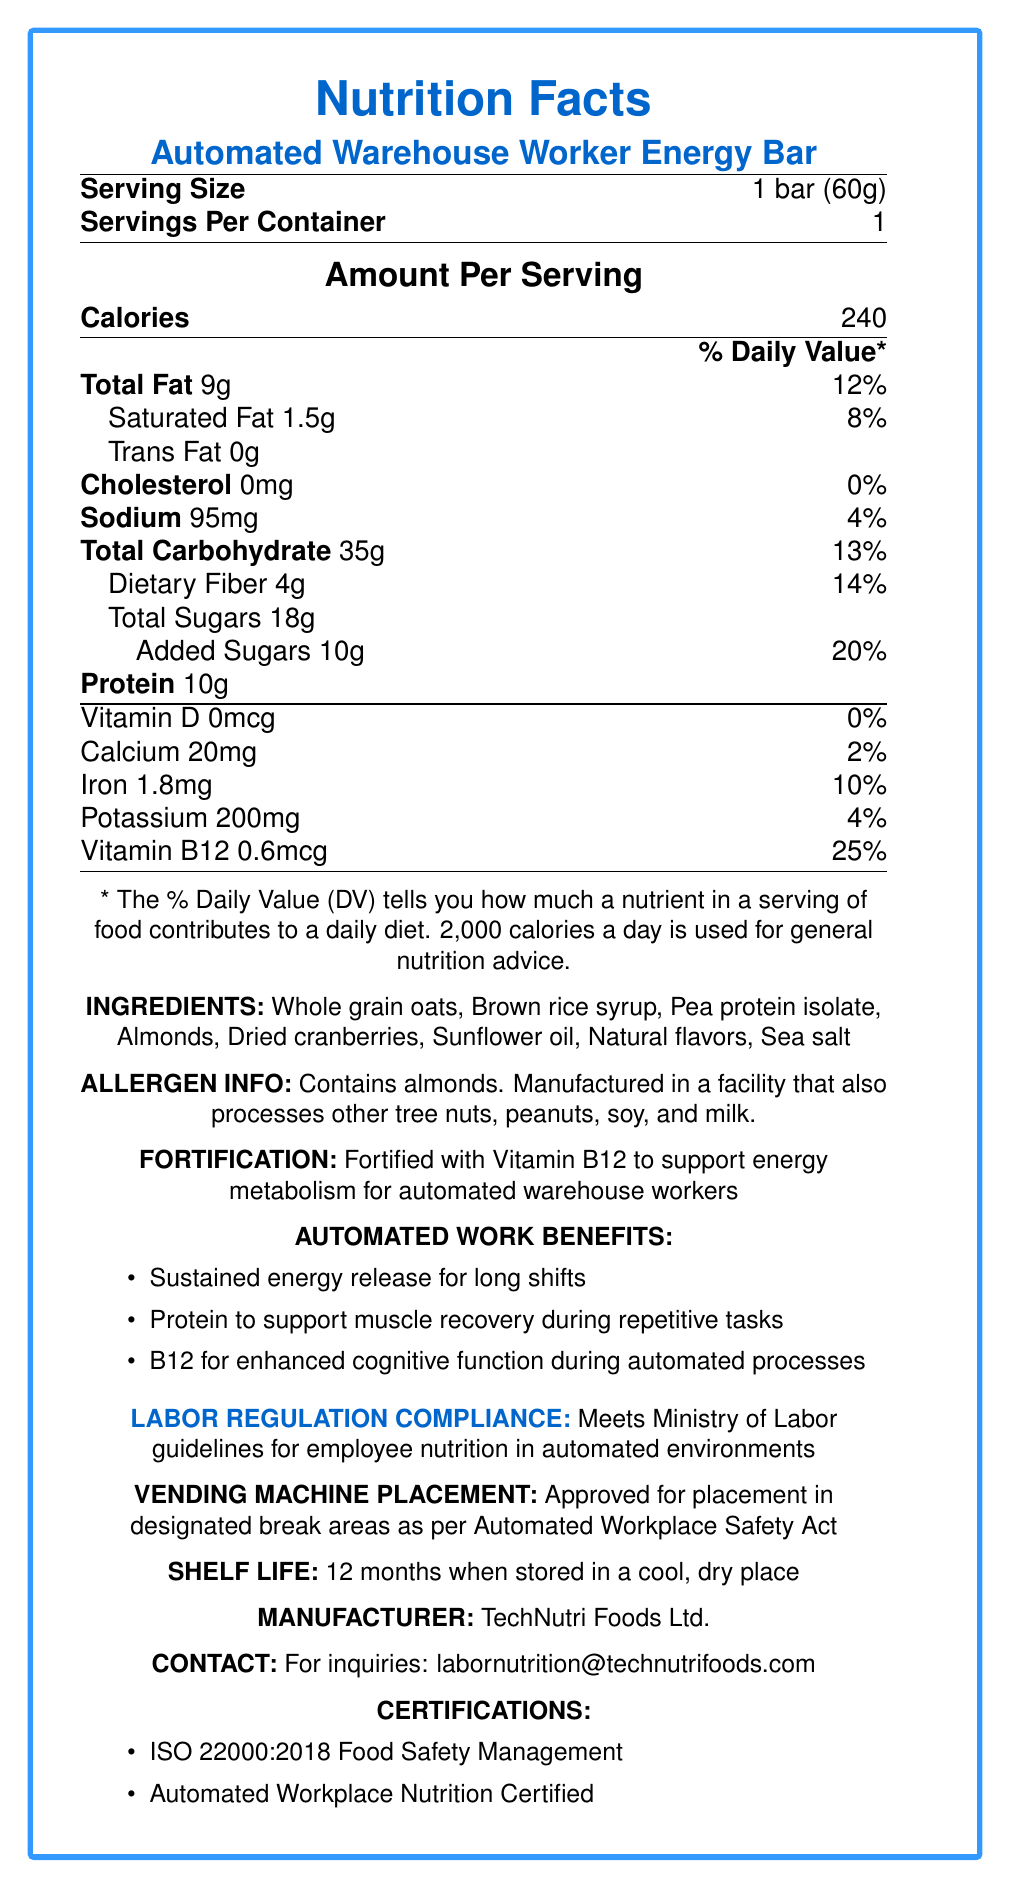how many calories are in one serving of the Automated Warehouse Worker Energy Bar? The document specifies "Calories: 240" under the "Amount Per Serving" section.
Answer: 240 what is the serving size of the energy bar? The serving size is mentioned at the top of the document as "Serving Size: 1 bar (60g)".
Answer: 1 bar (60g) what percentage of the daily value of protein does this energy bar provide? The document lists the amount of protein (10g) but does not specify its percentage of the daily value.
Answer: Not provided what are the main ingredients in the energy bar? These ingredients are listed in the "INGREDIENTS" section of the document.
Answer: Whole grain oats, Brown rice syrup, Pea protein isolate, Almonds, Dried cranberries, Sunflower oil, Natural flavors, Sea salt does the product contain any allergens? The "ALLERGEN INFO" section indicates it contains almonds and is manufactured in a facility that also processes other tree nuts, peanuts, soy, and milk.
Answer: Yes what is the daily value percentage of Vitamin B12 in this energy bar? The document specifies "Vitamin B12 0.6mcg" with a daily value of 25%.
Answer: 25% which of the following benefits for automated warehouse workers is mentioned in the document? A. Enhanced immune system B. Sustained energy release C. Reduced cholesterol The "AUTOMATED WORK BENEFITS" section lists "Sustained energy release for long shifts" among the benefits.
Answer: B. Sustained energy release which certifications does the product have? A. ISO 9001:2015 B. ISO 22000:2018 C. Organic D. Automated Workplace Nutrition Certified The "CERTIFICATIONS" section lists ISO 22000:2018 Food Safety Management and Automated Workplace Nutrition Certified.
Answer: B. ISO 22000:2018 and D. Automated Workplace Nutrition Certified is the product compliant with Ministry of Labor guidelines? The document states "Meets Ministry of Labor guidelines for employee nutrition in automated environments" under "LABOR REGULATION COMPLIANCE".
Answer: Yes is the vending machine placement of this product approved? The "VENDING MACHINE PLACEMENT" section states it is "Approved for placement in designated break areas as per Automated Workplace Safety Act".
Answer: Yes provide a summary of the main information contained in the document. The document is a comprehensive overview of the nutritional information, benefits, and regulatory compliance of the energy bar tailored for automated warehouse workers.
Answer: The document provides the nutrition facts for the Automated Warehouse Worker Energy Bar, including its caloric content, serving size, and detailed nutrient information such as fat, cholesterol, sodium, carbohydrates, fiber, sugars, protein, vitamins, and minerals. It also lists the ingredients, allergen information, fortification with Vitamin B12, benefits for automated warehouse workers, compliance with labor regulations, vending machine placement approval, shelf life, manufacturer details, contact information, and certifications. who is the manufacturer of the energy bar? The document specifies the manufacturer as "TechNutri Foods Ltd." under "MANUFACTURER".
Answer: TechNutri Foods Ltd. what is the shelf life of the product? The "SHELF LIFE" section specifies a shelf life of 12 months when stored in a cool, dry place.
Answer: 12 months how much calcium does one serving of this energy bar provide? The amount of calcium is listed as "Calcium 20mg" under the nutrients section.
Answer: 20mg what is the contact email for inquiries about this product? The "CONTACT" section provides the email for inquiries as "labornutrition@technutrifoods.com".
Answer: labornutrition@technutrifoods.com what other products does TechNutri Foods Ltd. manufacture? The document does not provide information on other products manufactured by TechNutri Foods Ltd.
Answer: Not enough information 